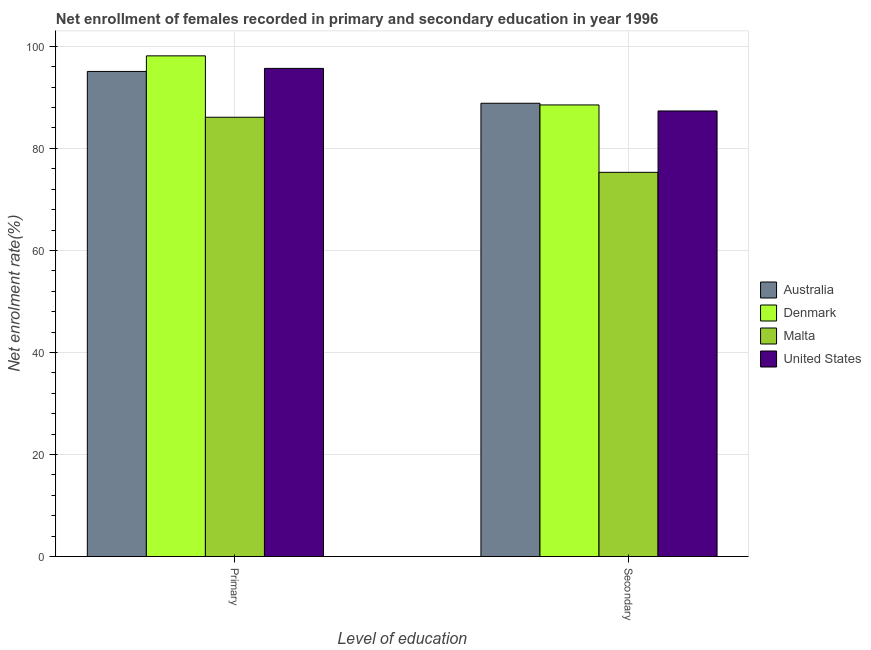How many groups of bars are there?
Keep it short and to the point. 2. Are the number of bars per tick equal to the number of legend labels?
Offer a very short reply. Yes. Are the number of bars on each tick of the X-axis equal?
Offer a very short reply. Yes. How many bars are there on the 1st tick from the left?
Provide a succinct answer. 4. What is the label of the 2nd group of bars from the left?
Provide a succinct answer. Secondary. What is the enrollment rate in primary education in Malta?
Offer a very short reply. 86.1. Across all countries, what is the maximum enrollment rate in primary education?
Your answer should be compact. 98.14. Across all countries, what is the minimum enrollment rate in primary education?
Your answer should be compact. 86.1. In which country was the enrollment rate in primary education minimum?
Offer a very short reply. Malta. What is the total enrollment rate in primary education in the graph?
Your response must be concise. 375. What is the difference between the enrollment rate in primary education in Australia and that in United States?
Offer a terse response. -0.6. What is the difference between the enrollment rate in primary education in Denmark and the enrollment rate in secondary education in Malta?
Your answer should be very brief. 22.83. What is the average enrollment rate in secondary education per country?
Keep it short and to the point. 85. What is the difference between the enrollment rate in secondary education and enrollment rate in primary education in Malta?
Provide a succinct answer. -10.8. What is the ratio of the enrollment rate in secondary education in Denmark to that in Malta?
Make the answer very short. 1.18. What does the 2nd bar from the left in Secondary represents?
Your answer should be compact. Denmark. What does the 2nd bar from the right in Primary represents?
Provide a succinct answer. Malta. Are all the bars in the graph horizontal?
Your response must be concise. No. How many countries are there in the graph?
Provide a short and direct response. 4. Are the values on the major ticks of Y-axis written in scientific E-notation?
Give a very brief answer. No. Does the graph contain any zero values?
Your response must be concise. No. Does the graph contain grids?
Offer a very short reply. Yes. Where does the legend appear in the graph?
Ensure brevity in your answer.  Center right. How are the legend labels stacked?
Keep it short and to the point. Vertical. What is the title of the graph?
Make the answer very short. Net enrollment of females recorded in primary and secondary education in year 1996. Does "St. Vincent and the Grenadines" appear as one of the legend labels in the graph?
Give a very brief answer. No. What is the label or title of the X-axis?
Provide a succinct answer. Level of education. What is the label or title of the Y-axis?
Ensure brevity in your answer.  Net enrolment rate(%). What is the Net enrolment rate(%) of Australia in Primary?
Offer a very short reply. 95.08. What is the Net enrolment rate(%) of Denmark in Primary?
Your response must be concise. 98.14. What is the Net enrolment rate(%) in Malta in Primary?
Your response must be concise. 86.1. What is the Net enrolment rate(%) of United States in Primary?
Your response must be concise. 95.68. What is the Net enrolment rate(%) of Australia in Secondary?
Provide a succinct answer. 88.85. What is the Net enrolment rate(%) of Denmark in Secondary?
Ensure brevity in your answer.  88.51. What is the Net enrolment rate(%) in Malta in Secondary?
Make the answer very short. 75.31. What is the Net enrolment rate(%) of United States in Secondary?
Provide a short and direct response. 87.34. Across all Level of education, what is the maximum Net enrolment rate(%) in Australia?
Offer a terse response. 95.08. Across all Level of education, what is the maximum Net enrolment rate(%) in Denmark?
Offer a terse response. 98.14. Across all Level of education, what is the maximum Net enrolment rate(%) of Malta?
Your response must be concise. 86.1. Across all Level of education, what is the maximum Net enrolment rate(%) in United States?
Your answer should be very brief. 95.68. Across all Level of education, what is the minimum Net enrolment rate(%) of Australia?
Your answer should be very brief. 88.85. Across all Level of education, what is the minimum Net enrolment rate(%) of Denmark?
Your response must be concise. 88.51. Across all Level of education, what is the minimum Net enrolment rate(%) in Malta?
Give a very brief answer. 75.31. Across all Level of education, what is the minimum Net enrolment rate(%) in United States?
Offer a very short reply. 87.34. What is the total Net enrolment rate(%) of Australia in the graph?
Your answer should be compact. 183.93. What is the total Net enrolment rate(%) of Denmark in the graph?
Provide a succinct answer. 186.65. What is the total Net enrolment rate(%) in Malta in the graph?
Give a very brief answer. 161.41. What is the total Net enrolment rate(%) of United States in the graph?
Offer a very short reply. 183.02. What is the difference between the Net enrolment rate(%) of Australia in Primary and that in Secondary?
Your response must be concise. 6.24. What is the difference between the Net enrolment rate(%) in Denmark in Primary and that in Secondary?
Offer a very short reply. 9.62. What is the difference between the Net enrolment rate(%) of Malta in Primary and that in Secondary?
Keep it short and to the point. 10.8. What is the difference between the Net enrolment rate(%) of United States in Primary and that in Secondary?
Provide a short and direct response. 8.34. What is the difference between the Net enrolment rate(%) in Australia in Primary and the Net enrolment rate(%) in Denmark in Secondary?
Your answer should be compact. 6.57. What is the difference between the Net enrolment rate(%) of Australia in Primary and the Net enrolment rate(%) of Malta in Secondary?
Give a very brief answer. 19.78. What is the difference between the Net enrolment rate(%) in Australia in Primary and the Net enrolment rate(%) in United States in Secondary?
Provide a short and direct response. 7.74. What is the difference between the Net enrolment rate(%) in Denmark in Primary and the Net enrolment rate(%) in Malta in Secondary?
Make the answer very short. 22.83. What is the difference between the Net enrolment rate(%) of Denmark in Primary and the Net enrolment rate(%) of United States in Secondary?
Your answer should be compact. 10.8. What is the difference between the Net enrolment rate(%) in Malta in Primary and the Net enrolment rate(%) in United States in Secondary?
Give a very brief answer. -1.23. What is the average Net enrolment rate(%) in Australia per Level of education?
Keep it short and to the point. 91.96. What is the average Net enrolment rate(%) of Denmark per Level of education?
Your answer should be compact. 93.33. What is the average Net enrolment rate(%) in Malta per Level of education?
Make the answer very short. 80.71. What is the average Net enrolment rate(%) in United States per Level of education?
Offer a very short reply. 91.51. What is the difference between the Net enrolment rate(%) in Australia and Net enrolment rate(%) in Denmark in Primary?
Provide a short and direct response. -3.06. What is the difference between the Net enrolment rate(%) in Australia and Net enrolment rate(%) in Malta in Primary?
Make the answer very short. 8.98. What is the difference between the Net enrolment rate(%) of Australia and Net enrolment rate(%) of United States in Primary?
Ensure brevity in your answer.  -0.6. What is the difference between the Net enrolment rate(%) in Denmark and Net enrolment rate(%) in Malta in Primary?
Make the answer very short. 12.03. What is the difference between the Net enrolment rate(%) of Denmark and Net enrolment rate(%) of United States in Primary?
Your response must be concise. 2.46. What is the difference between the Net enrolment rate(%) in Malta and Net enrolment rate(%) in United States in Primary?
Provide a succinct answer. -9.58. What is the difference between the Net enrolment rate(%) of Australia and Net enrolment rate(%) of Denmark in Secondary?
Your response must be concise. 0.33. What is the difference between the Net enrolment rate(%) of Australia and Net enrolment rate(%) of Malta in Secondary?
Offer a terse response. 13.54. What is the difference between the Net enrolment rate(%) in Australia and Net enrolment rate(%) in United States in Secondary?
Provide a succinct answer. 1.51. What is the difference between the Net enrolment rate(%) in Denmark and Net enrolment rate(%) in Malta in Secondary?
Ensure brevity in your answer.  13.21. What is the difference between the Net enrolment rate(%) of Denmark and Net enrolment rate(%) of United States in Secondary?
Offer a very short reply. 1.18. What is the difference between the Net enrolment rate(%) of Malta and Net enrolment rate(%) of United States in Secondary?
Ensure brevity in your answer.  -12.03. What is the ratio of the Net enrolment rate(%) of Australia in Primary to that in Secondary?
Offer a very short reply. 1.07. What is the ratio of the Net enrolment rate(%) in Denmark in Primary to that in Secondary?
Your response must be concise. 1.11. What is the ratio of the Net enrolment rate(%) of Malta in Primary to that in Secondary?
Offer a terse response. 1.14. What is the ratio of the Net enrolment rate(%) of United States in Primary to that in Secondary?
Keep it short and to the point. 1.1. What is the difference between the highest and the second highest Net enrolment rate(%) in Australia?
Ensure brevity in your answer.  6.24. What is the difference between the highest and the second highest Net enrolment rate(%) of Denmark?
Offer a very short reply. 9.62. What is the difference between the highest and the second highest Net enrolment rate(%) of Malta?
Give a very brief answer. 10.8. What is the difference between the highest and the second highest Net enrolment rate(%) in United States?
Provide a short and direct response. 8.34. What is the difference between the highest and the lowest Net enrolment rate(%) of Australia?
Offer a very short reply. 6.24. What is the difference between the highest and the lowest Net enrolment rate(%) in Denmark?
Your answer should be very brief. 9.62. What is the difference between the highest and the lowest Net enrolment rate(%) of Malta?
Offer a very short reply. 10.8. What is the difference between the highest and the lowest Net enrolment rate(%) of United States?
Your response must be concise. 8.34. 